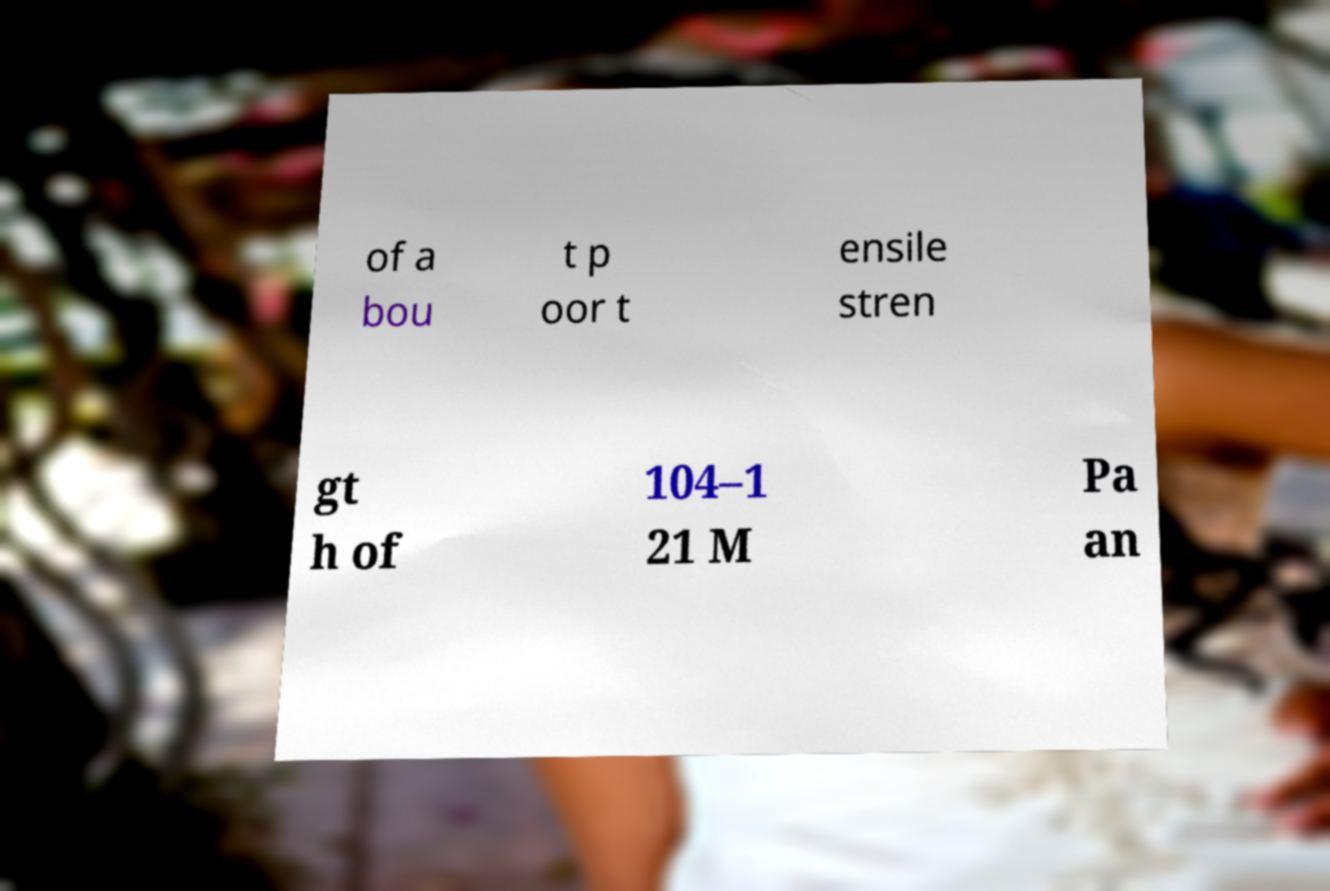There's text embedded in this image that I need extracted. Can you transcribe it verbatim? of a bou t p oor t ensile stren gt h of 104–1 21 M Pa an 